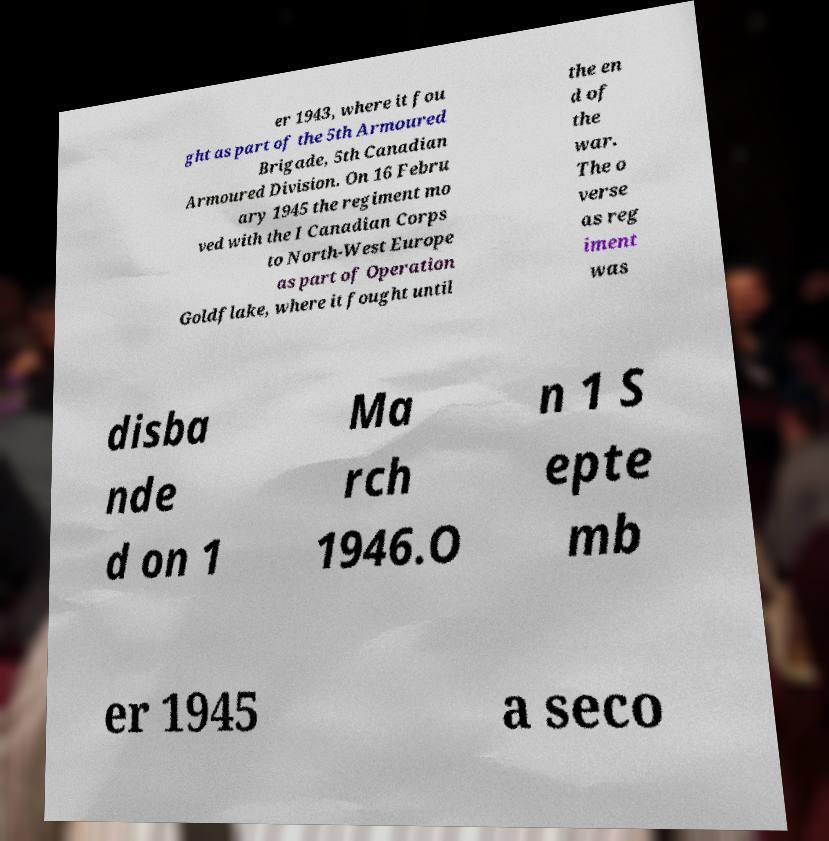Could you extract and type out the text from this image? er 1943, where it fou ght as part of the 5th Armoured Brigade, 5th Canadian Armoured Division. On 16 Febru ary 1945 the regiment mo ved with the I Canadian Corps to North-West Europe as part of Operation Goldflake, where it fought until the en d of the war. The o verse as reg iment was disba nde d on 1 Ma rch 1946.O n 1 S epte mb er 1945 a seco 